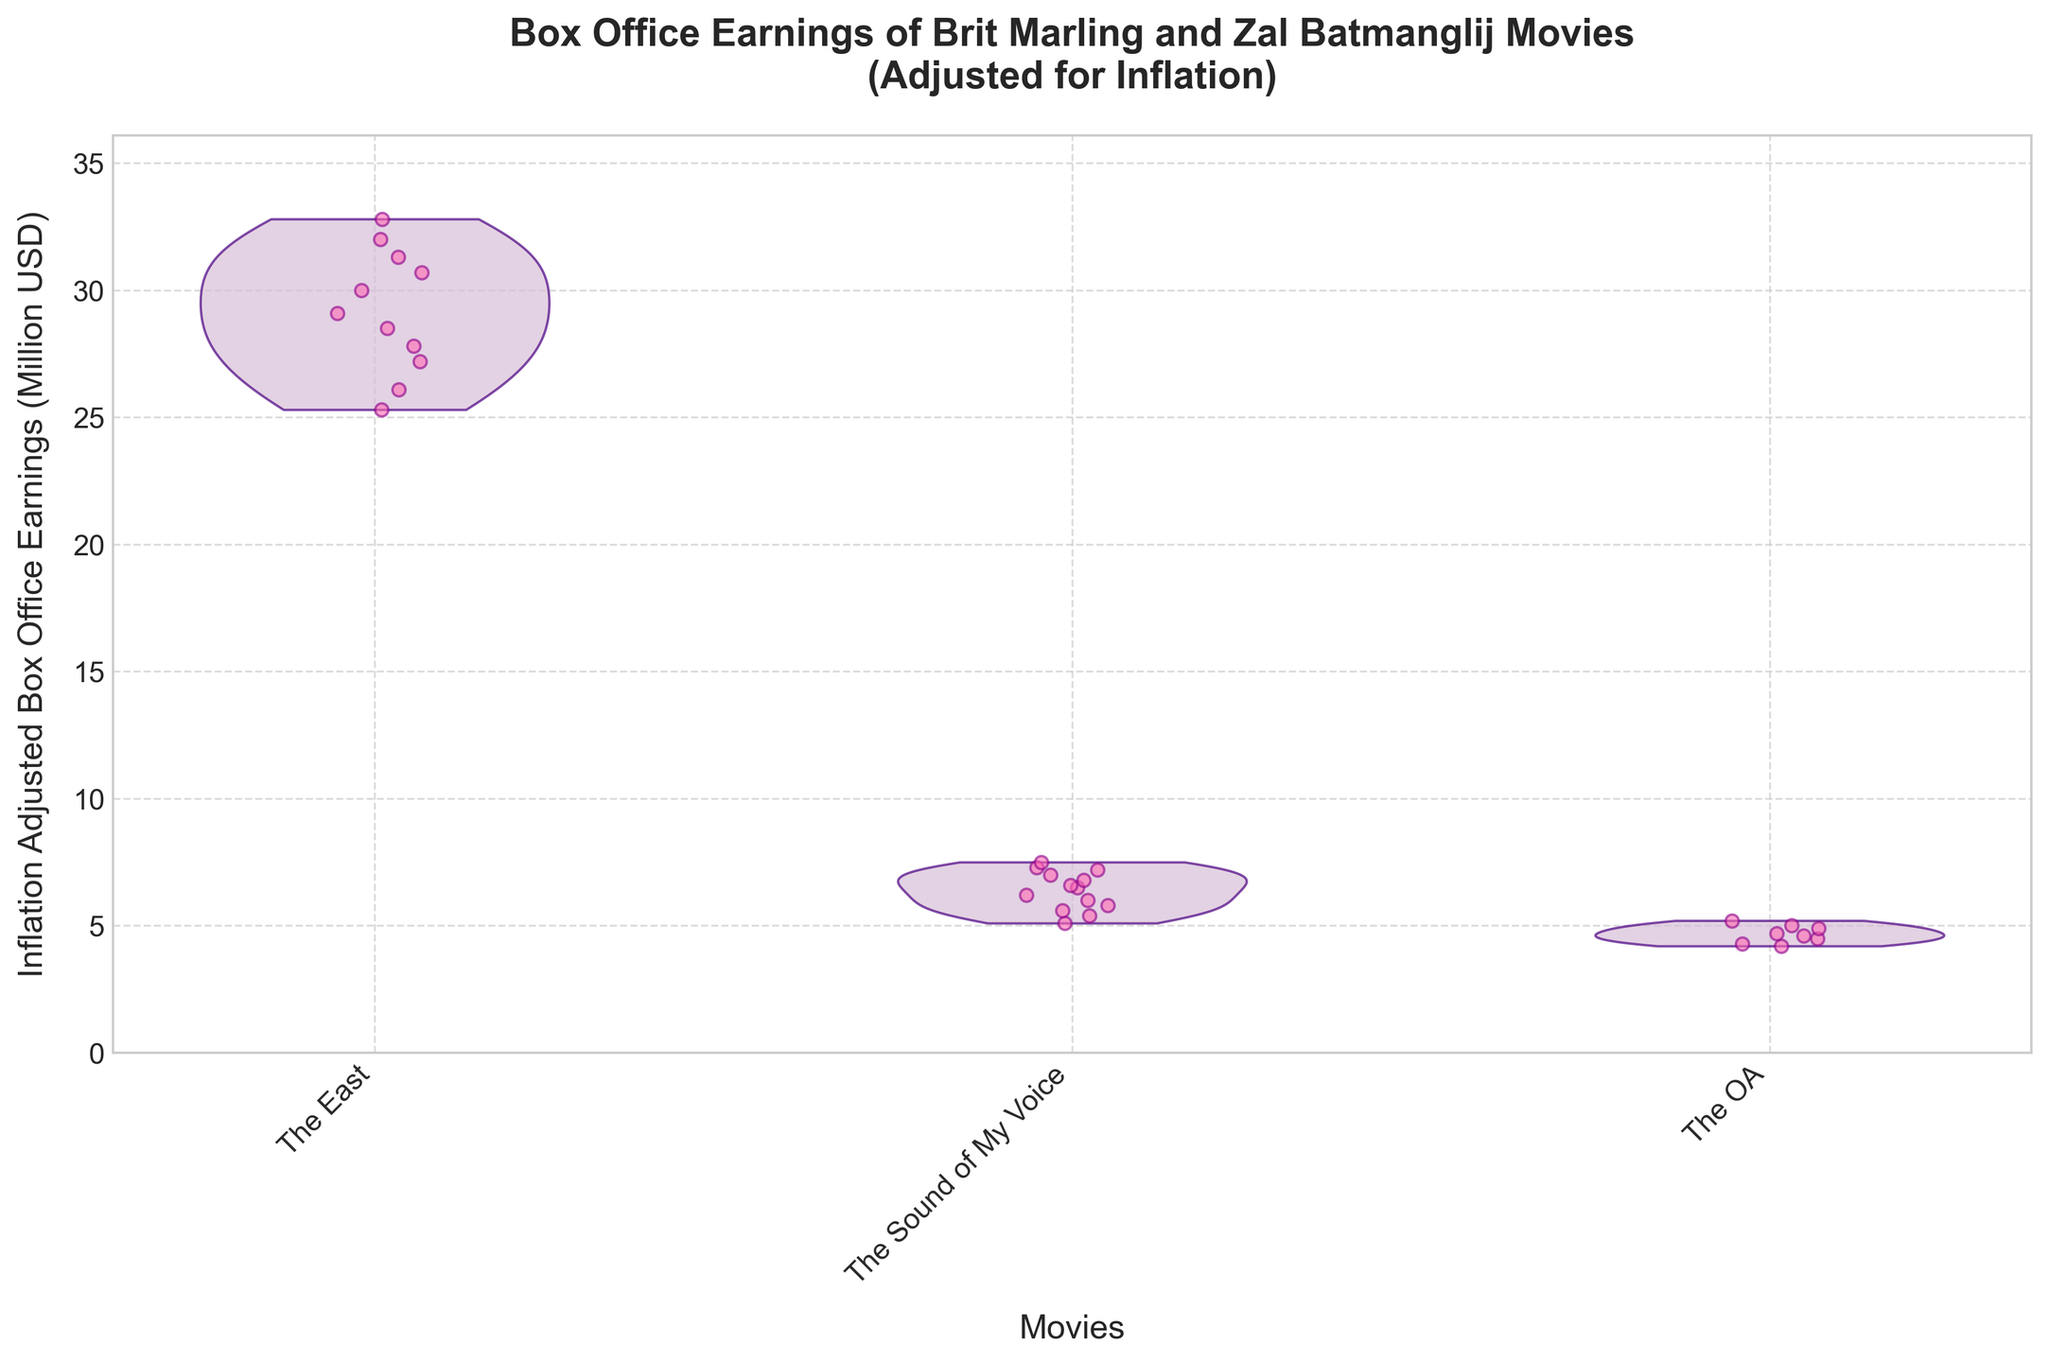What is the title of the figure? The title of the figure is shown at the top center.
Answer: Box Office Earnings of Brit Marling and Zal Batmanglij Movies (Adjusted for Inflation) What are the movies shown on the x-axis? The x-axis labels indicate the movies. There are three names present.
Answer: "The East", "The Sound of My Voice", "The OA" What are the y-axis limits? The y-axis limits are determined by looking at the range shown on the axis.
Answer: 0 to approximately 36 million USD How many data points are there for "The East"? By counting the jittered points for "The East", we find there are 11 data points.
Answer: 11 Which movie has the highest peak in box office earnings adjusted for inflation? We look for the highest point in the violin plots. "The East" has the tallest peak.
Answer: "The East" What's the range of earnings for "The Sound of My Voice"? The range can be detected by looking at the top and bottom points of the violin plot for "The Sound of My Voice". The lowest point is 5.1 million USD in 2011 and the highest is 7.5 million USD in 2023.
Answer: 5.1 to 7.5 million USD What's the median inflation-adjusted box office earnings for "The OA"? To estimate the median for "The OA", identify the middle value of the jittered points along the y-axis.
Answer: Approximately 4.6 million USD Which movie has shown the most growth over the years? Comparing the spread and progression of the violin plots and points, "The East" shows significant upward growth in earnings over time.
Answer: "The East" What is the general trend of "The OA" from 2016 to 2023? The violin plot's shape and points for "The OA" indicate mostly stable, slight growth over the years.
Answer: Slight growth Are there any outliers in the data? Outliers would appear as points far away from the main bulk of the data in each violin plot. None of the movies show this characteristic, their points are closely packed.
Answer: No 